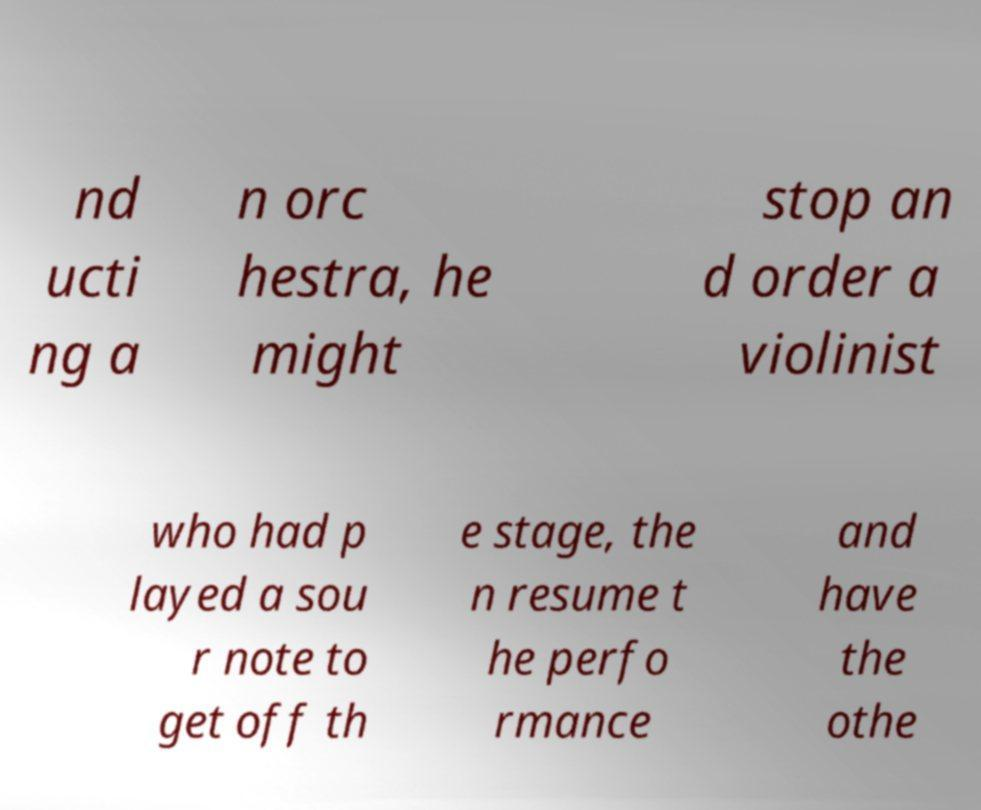I need the written content from this picture converted into text. Can you do that? nd ucti ng a n orc hestra, he might stop an d order a violinist who had p layed a sou r note to get off th e stage, the n resume t he perfo rmance and have the othe 